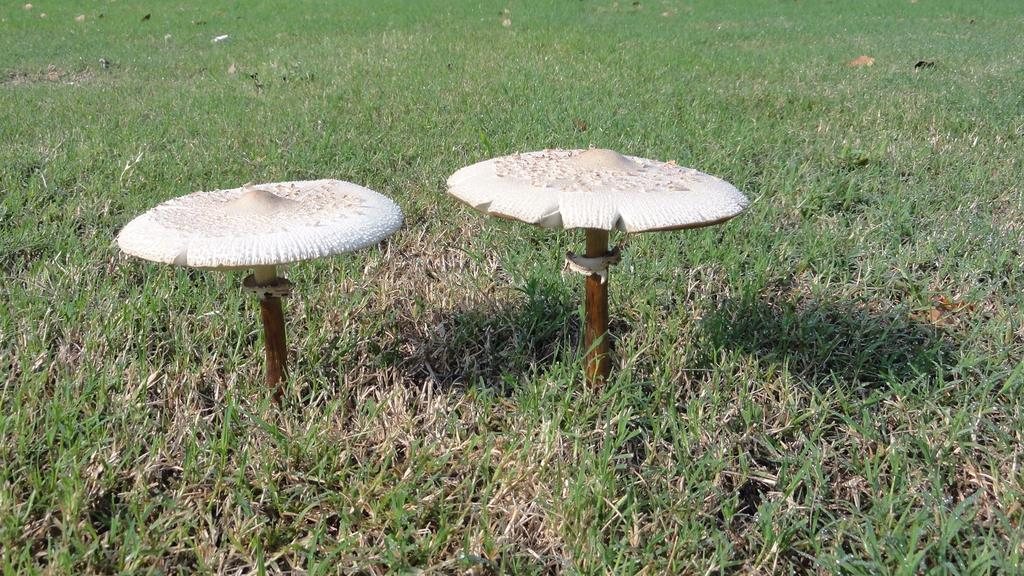What is located in the foreground of the picture? There are mushrooms and grass in the foreground of the picture. What type of vegetation can be seen in the foreground? Both mushrooms and grass are visible in the foreground. What can be seen in the background of the picture? There are dry leaves and grass in the background of the picture. How does the vegetation change between the foreground and background? In the foreground, there are mushrooms and grass, while in the background, there are dry leaves and grass. What type of industry can be seen in the background of the picture? There is no industry present in the image; it features mushrooms, grass, and dry leaves in a natural setting. Can you see any hands holding the mushrooms in the picture? There are no hands visible in the image; it only shows mushrooms, grass, and dry leaves. 